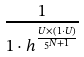Convert formula to latex. <formula><loc_0><loc_0><loc_500><loc_500>\frac { 1 } { 1 \cdot h ^ { \frac { U \times ( 1 \cdot U ) } { 5 ^ { N + 1 } } } }</formula> 